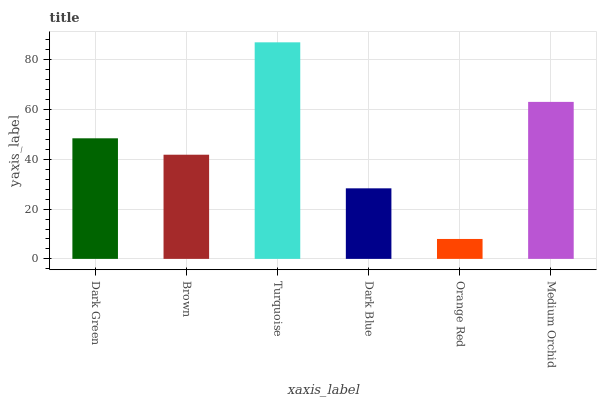Is Orange Red the minimum?
Answer yes or no. Yes. Is Turquoise the maximum?
Answer yes or no. Yes. Is Brown the minimum?
Answer yes or no. No. Is Brown the maximum?
Answer yes or no. No. Is Dark Green greater than Brown?
Answer yes or no. Yes. Is Brown less than Dark Green?
Answer yes or no. Yes. Is Brown greater than Dark Green?
Answer yes or no. No. Is Dark Green less than Brown?
Answer yes or no. No. Is Dark Green the high median?
Answer yes or no. Yes. Is Brown the low median?
Answer yes or no. Yes. Is Brown the high median?
Answer yes or no. No. Is Orange Red the low median?
Answer yes or no. No. 